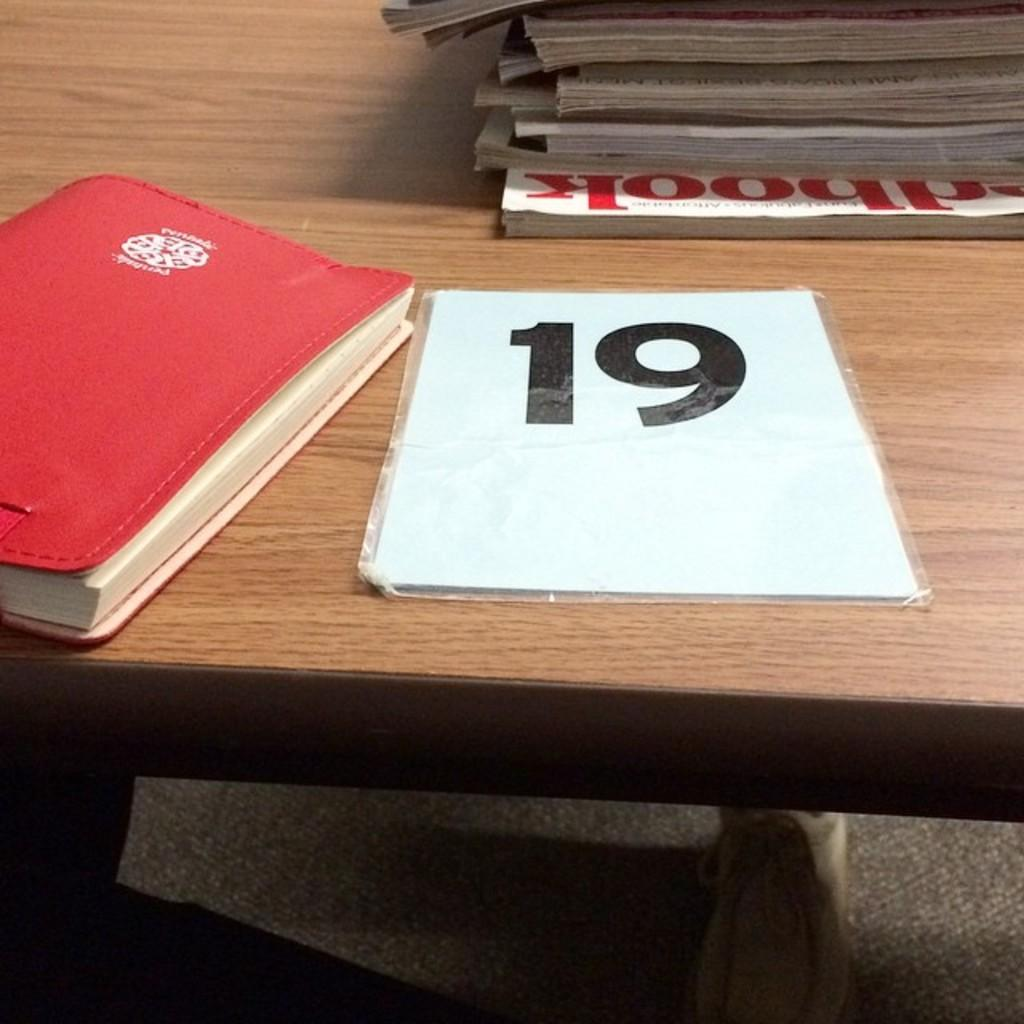What objects can be seen in the image? There are books in the image. Where are the books located? The books are on a table. How do the books slip and join together in the image? The books do not slip or join together in the image; they are simply placed on the table. 